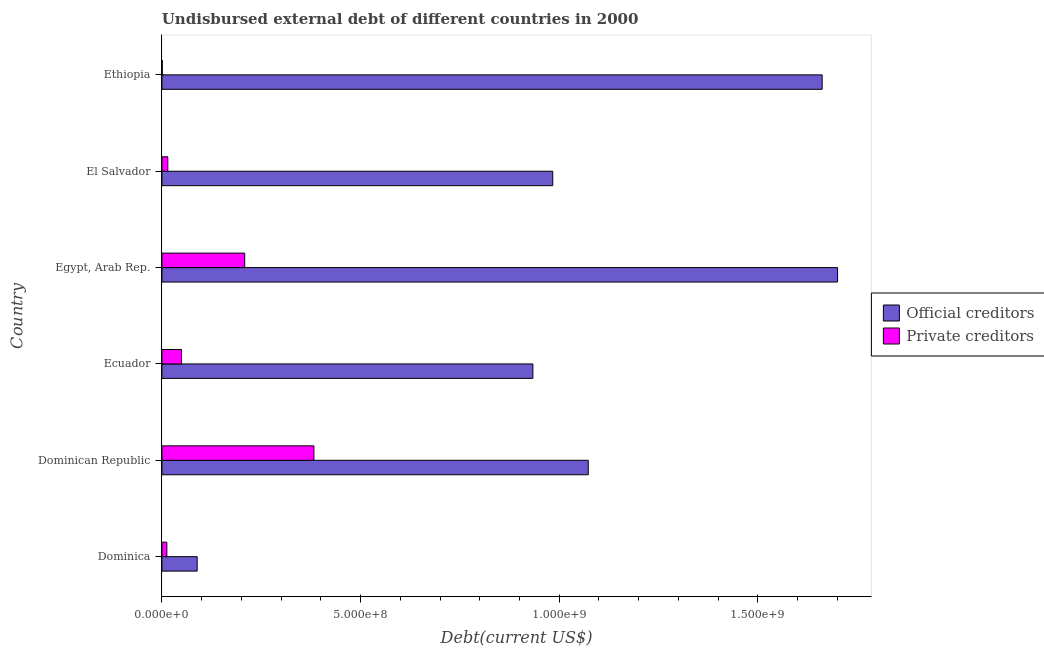Are the number of bars per tick equal to the number of legend labels?
Make the answer very short. Yes. Are the number of bars on each tick of the Y-axis equal?
Provide a short and direct response. Yes. How many bars are there on the 4th tick from the bottom?
Ensure brevity in your answer.  2. What is the label of the 5th group of bars from the top?
Your answer should be compact. Dominican Republic. In how many cases, is the number of bars for a given country not equal to the number of legend labels?
Give a very brief answer. 0. What is the undisbursed external debt of official creditors in El Salvador?
Offer a very short reply. 9.84e+08. Across all countries, what is the maximum undisbursed external debt of official creditors?
Offer a very short reply. 1.70e+09. Across all countries, what is the minimum undisbursed external debt of private creditors?
Provide a succinct answer. 9.53e+05. In which country was the undisbursed external debt of private creditors maximum?
Your answer should be compact. Dominican Republic. In which country was the undisbursed external debt of private creditors minimum?
Offer a terse response. Ethiopia. What is the total undisbursed external debt of private creditors in the graph?
Provide a short and direct response. 6.69e+08. What is the difference between the undisbursed external debt of private creditors in Ecuador and that in Egypt, Arab Rep.?
Make the answer very short. -1.59e+08. What is the difference between the undisbursed external debt of official creditors in Ethiopia and the undisbursed external debt of private creditors in Egypt, Arab Rep.?
Provide a short and direct response. 1.45e+09. What is the average undisbursed external debt of official creditors per country?
Your answer should be very brief. 1.07e+09. What is the difference between the undisbursed external debt of official creditors and undisbursed external debt of private creditors in Ethiopia?
Ensure brevity in your answer.  1.66e+09. In how many countries, is the undisbursed external debt of private creditors greater than 1100000000 US$?
Give a very brief answer. 0. Is the difference between the undisbursed external debt of private creditors in Egypt, Arab Rep. and Ethiopia greater than the difference between the undisbursed external debt of official creditors in Egypt, Arab Rep. and Ethiopia?
Make the answer very short. Yes. What is the difference between the highest and the second highest undisbursed external debt of official creditors?
Keep it short and to the point. 3.88e+07. What is the difference between the highest and the lowest undisbursed external debt of official creditors?
Provide a succinct answer. 1.61e+09. What does the 2nd bar from the top in El Salvador represents?
Provide a succinct answer. Official creditors. What does the 2nd bar from the bottom in Egypt, Arab Rep. represents?
Give a very brief answer. Private creditors. Are all the bars in the graph horizontal?
Keep it short and to the point. Yes. How many countries are there in the graph?
Your answer should be very brief. 6. Are the values on the major ticks of X-axis written in scientific E-notation?
Your answer should be very brief. Yes. Does the graph contain any zero values?
Offer a very short reply. No. What is the title of the graph?
Ensure brevity in your answer.  Undisbursed external debt of different countries in 2000. Does "Import" appear as one of the legend labels in the graph?
Your answer should be compact. No. What is the label or title of the X-axis?
Provide a short and direct response. Debt(current US$). What is the label or title of the Y-axis?
Provide a succinct answer. Country. What is the Debt(current US$) in Official creditors in Dominica?
Give a very brief answer. 8.88e+07. What is the Debt(current US$) in Private creditors in Dominica?
Make the answer very short. 1.25e+07. What is the Debt(current US$) of Official creditors in Dominican Republic?
Give a very brief answer. 1.07e+09. What is the Debt(current US$) in Private creditors in Dominican Republic?
Ensure brevity in your answer.  3.83e+08. What is the Debt(current US$) of Official creditors in Ecuador?
Provide a short and direct response. 9.34e+08. What is the Debt(current US$) of Private creditors in Ecuador?
Ensure brevity in your answer.  4.93e+07. What is the Debt(current US$) in Official creditors in Egypt, Arab Rep.?
Offer a very short reply. 1.70e+09. What is the Debt(current US$) in Private creditors in Egypt, Arab Rep.?
Ensure brevity in your answer.  2.08e+08. What is the Debt(current US$) of Official creditors in El Salvador?
Your answer should be very brief. 9.84e+08. What is the Debt(current US$) of Private creditors in El Salvador?
Ensure brevity in your answer.  1.49e+07. What is the Debt(current US$) in Official creditors in Ethiopia?
Offer a very short reply. 1.66e+09. What is the Debt(current US$) of Private creditors in Ethiopia?
Offer a terse response. 9.53e+05. Across all countries, what is the maximum Debt(current US$) of Official creditors?
Ensure brevity in your answer.  1.70e+09. Across all countries, what is the maximum Debt(current US$) of Private creditors?
Make the answer very short. 3.83e+08. Across all countries, what is the minimum Debt(current US$) in Official creditors?
Ensure brevity in your answer.  8.88e+07. Across all countries, what is the minimum Debt(current US$) of Private creditors?
Offer a terse response. 9.53e+05. What is the total Debt(current US$) in Official creditors in the graph?
Offer a terse response. 6.44e+09. What is the total Debt(current US$) of Private creditors in the graph?
Provide a short and direct response. 6.69e+08. What is the difference between the Debt(current US$) in Official creditors in Dominica and that in Dominican Republic?
Provide a succinct answer. -9.84e+08. What is the difference between the Debt(current US$) of Private creditors in Dominica and that in Dominican Republic?
Make the answer very short. -3.70e+08. What is the difference between the Debt(current US$) of Official creditors in Dominica and that in Ecuador?
Your response must be concise. -8.45e+08. What is the difference between the Debt(current US$) of Private creditors in Dominica and that in Ecuador?
Provide a succinct answer. -3.68e+07. What is the difference between the Debt(current US$) in Official creditors in Dominica and that in Egypt, Arab Rep.?
Keep it short and to the point. -1.61e+09. What is the difference between the Debt(current US$) of Private creditors in Dominica and that in Egypt, Arab Rep.?
Your response must be concise. -1.96e+08. What is the difference between the Debt(current US$) of Official creditors in Dominica and that in El Salvador?
Offer a terse response. -8.95e+08. What is the difference between the Debt(current US$) in Private creditors in Dominica and that in El Salvador?
Your answer should be very brief. -2.40e+06. What is the difference between the Debt(current US$) of Official creditors in Dominica and that in Ethiopia?
Provide a succinct answer. -1.57e+09. What is the difference between the Debt(current US$) of Private creditors in Dominica and that in Ethiopia?
Ensure brevity in your answer.  1.15e+07. What is the difference between the Debt(current US$) of Official creditors in Dominican Republic and that in Ecuador?
Your answer should be compact. 1.39e+08. What is the difference between the Debt(current US$) of Private creditors in Dominican Republic and that in Ecuador?
Offer a terse response. 3.33e+08. What is the difference between the Debt(current US$) in Official creditors in Dominican Republic and that in Egypt, Arab Rep.?
Make the answer very short. -6.27e+08. What is the difference between the Debt(current US$) of Private creditors in Dominican Republic and that in Egypt, Arab Rep.?
Provide a short and direct response. 1.74e+08. What is the difference between the Debt(current US$) in Official creditors in Dominican Republic and that in El Salvador?
Your answer should be compact. 8.94e+07. What is the difference between the Debt(current US$) of Private creditors in Dominican Republic and that in El Salvador?
Give a very brief answer. 3.68e+08. What is the difference between the Debt(current US$) in Official creditors in Dominican Republic and that in Ethiopia?
Give a very brief answer. -5.89e+08. What is the difference between the Debt(current US$) of Private creditors in Dominican Republic and that in Ethiopia?
Provide a short and direct response. 3.82e+08. What is the difference between the Debt(current US$) in Official creditors in Ecuador and that in Egypt, Arab Rep.?
Offer a very short reply. -7.67e+08. What is the difference between the Debt(current US$) in Private creditors in Ecuador and that in Egypt, Arab Rep.?
Offer a very short reply. -1.59e+08. What is the difference between the Debt(current US$) in Official creditors in Ecuador and that in El Salvador?
Provide a short and direct response. -5.00e+07. What is the difference between the Debt(current US$) of Private creditors in Ecuador and that in El Salvador?
Give a very brief answer. 3.44e+07. What is the difference between the Debt(current US$) in Official creditors in Ecuador and that in Ethiopia?
Your response must be concise. -7.28e+08. What is the difference between the Debt(current US$) in Private creditors in Ecuador and that in Ethiopia?
Ensure brevity in your answer.  4.83e+07. What is the difference between the Debt(current US$) in Official creditors in Egypt, Arab Rep. and that in El Salvador?
Ensure brevity in your answer.  7.17e+08. What is the difference between the Debt(current US$) of Private creditors in Egypt, Arab Rep. and that in El Salvador?
Offer a terse response. 1.94e+08. What is the difference between the Debt(current US$) in Official creditors in Egypt, Arab Rep. and that in Ethiopia?
Make the answer very short. 3.88e+07. What is the difference between the Debt(current US$) of Private creditors in Egypt, Arab Rep. and that in Ethiopia?
Offer a very short reply. 2.07e+08. What is the difference between the Debt(current US$) of Official creditors in El Salvador and that in Ethiopia?
Offer a very short reply. -6.78e+08. What is the difference between the Debt(current US$) of Private creditors in El Salvador and that in Ethiopia?
Your answer should be very brief. 1.39e+07. What is the difference between the Debt(current US$) of Official creditors in Dominica and the Debt(current US$) of Private creditors in Dominican Republic?
Offer a terse response. -2.94e+08. What is the difference between the Debt(current US$) of Official creditors in Dominica and the Debt(current US$) of Private creditors in Ecuador?
Offer a very short reply. 3.95e+07. What is the difference between the Debt(current US$) of Official creditors in Dominica and the Debt(current US$) of Private creditors in Egypt, Arab Rep.?
Your answer should be compact. -1.20e+08. What is the difference between the Debt(current US$) of Official creditors in Dominica and the Debt(current US$) of Private creditors in El Salvador?
Offer a terse response. 7.39e+07. What is the difference between the Debt(current US$) in Official creditors in Dominica and the Debt(current US$) in Private creditors in Ethiopia?
Provide a short and direct response. 8.78e+07. What is the difference between the Debt(current US$) in Official creditors in Dominican Republic and the Debt(current US$) in Private creditors in Ecuador?
Your response must be concise. 1.02e+09. What is the difference between the Debt(current US$) in Official creditors in Dominican Republic and the Debt(current US$) in Private creditors in Egypt, Arab Rep.?
Offer a very short reply. 8.65e+08. What is the difference between the Debt(current US$) of Official creditors in Dominican Republic and the Debt(current US$) of Private creditors in El Salvador?
Ensure brevity in your answer.  1.06e+09. What is the difference between the Debt(current US$) in Official creditors in Dominican Republic and the Debt(current US$) in Private creditors in Ethiopia?
Offer a terse response. 1.07e+09. What is the difference between the Debt(current US$) of Official creditors in Ecuador and the Debt(current US$) of Private creditors in Egypt, Arab Rep.?
Your answer should be very brief. 7.25e+08. What is the difference between the Debt(current US$) in Official creditors in Ecuador and the Debt(current US$) in Private creditors in El Salvador?
Provide a short and direct response. 9.19e+08. What is the difference between the Debt(current US$) in Official creditors in Ecuador and the Debt(current US$) in Private creditors in Ethiopia?
Your response must be concise. 9.33e+08. What is the difference between the Debt(current US$) in Official creditors in Egypt, Arab Rep. and the Debt(current US$) in Private creditors in El Salvador?
Provide a short and direct response. 1.69e+09. What is the difference between the Debt(current US$) of Official creditors in Egypt, Arab Rep. and the Debt(current US$) of Private creditors in Ethiopia?
Give a very brief answer. 1.70e+09. What is the difference between the Debt(current US$) in Official creditors in El Salvador and the Debt(current US$) in Private creditors in Ethiopia?
Your answer should be very brief. 9.83e+08. What is the average Debt(current US$) of Official creditors per country?
Keep it short and to the point. 1.07e+09. What is the average Debt(current US$) in Private creditors per country?
Ensure brevity in your answer.  1.11e+08. What is the difference between the Debt(current US$) in Official creditors and Debt(current US$) in Private creditors in Dominica?
Keep it short and to the point. 7.63e+07. What is the difference between the Debt(current US$) in Official creditors and Debt(current US$) in Private creditors in Dominican Republic?
Give a very brief answer. 6.90e+08. What is the difference between the Debt(current US$) in Official creditors and Debt(current US$) in Private creditors in Ecuador?
Your response must be concise. 8.84e+08. What is the difference between the Debt(current US$) in Official creditors and Debt(current US$) in Private creditors in Egypt, Arab Rep.?
Keep it short and to the point. 1.49e+09. What is the difference between the Debt(current US$) in Official creditors and Debt(current US$) in Private creditors in El Salvador?
Your response must be concise. 9.69e+08. What is the difference between the Debt(current US$) of Official creditors and Debt(current US$) of Private creditors in Ethiopia?
Offer a terse response. 1.66e+09. What is the ratio of the Debt(current US$) in Official creditors in Dominica to that in Dominican Republic?
Give a very brief answer. 0.08. What is the ratio of the Debt(current US$) in Private creditors in Dominica to that in Dominican Republic?
Offer a very short reply. 0.03. What is the ratio of the Debt(current US$) of Official creditors in Dominica to that in Ecuador?
Offer a very short reply. 0.1. What is the ratio of the Debt(current US$) of Private creditors in Dominica to that in Ecuador?
Your answer should be compact. 0.25. What is the ratio of the Debt(current US$) of Official creditors in Dominica to that in Egypt, Arab Rep.?
Your answer should be very brief. 0.05. What is the ratio of the Debt(current US$) in Private creditors in Dominica to that in Egypt, Arab Rep.?
Offer a terse response. 0.06. What is the ratio of the Debt(current US$) in Official creditors in Dominica to that in El Salvador?
Provide a succinct answer. 0.09. What is the ratio of the Debt(current US$) in Private creditors in Dominica to that in El Salvador?
Make the answer very short. 0.84. What is the ratio of the Debt(current US$) in Official creditors in Dominica to that in Ethiopia?
Ensure brevity in your answer.  0.05. What is the ratio of the Debt(current US$) in Private creditors in Dominica to that in Ethiopia?
Offer a very short reply. 13.07. What is the ratio of the Debt(current US$) of Official creditors in Dominican Republic to that in Ecuador?
Provide a short and direct response. 1.15. What is the ratio of the Debt(current US$) of Private creditors in Dominican Republic to that in Ecuador?
Give a very brief answer. 7.77. What is the ratio of the Debt(current US$) in Official creditors in Dominican Republic to that in Egypt, Arab Rep.?
Ensure brevity in your answer.  0.63. What is the ratio of the Debt(current US$) in Private creditors in Dominican Republic to that in Egypt, Arab Rep.?
Offer a very short reply. 1.84. What is the ratio of the Debt(current US$) in Official creditors in Dominican Republic to that in El Salvador?
Provide a succinct answer. 1.09. What is the ratio of the Debt(current US$) of Private creditors in Dominican Republic to that in El Salvador?
Make the answer very short. 25.76. What is the ratio of the Debt(current US$) of Official creditors in Dominican Republic to that in Ethiopia?
Your answer should be compact. 0.65. What is the ratio of the Debt(current US$) in Private creditors in Dominican Republic to that in Ethiopia?
Offer a very short reply. 401.48. What is the ratio of the Debt(current US$) of Official creditors in Ecuador to that in Egypt, Arab Rep.?
Your response must be concise. 0.55. What is the ratio of the Debt(current US$) of Private creditors in Ecuador to that in Egypt, Arab Rep.?
Offer a very short reply. 0.24. What is the ratio of the Debt(current US$) in Official creditors in Ecuador to that in El Salvador?
Offer a very short reply. 0.95. What is the ratio of the Debt(current US$) in Private creditors in Ecuador to that in El Salvador?
Your answer should be compact. 3.32. What is the ratio of the Debt(current US$) of Official creditors in Ecuador to that in Ethiopia?
Provide a short and direct response. 0.56. What is the ratio of the Debt(current US$) of Private creditors in Ecuador to that in Ethiopia?
Provide a succinct answer. 51.69. What is the ratio of the Debt(current US$) of Official creditors in Egypt, Arab Rep. to that in El Salvador?
Your answer should be compact. 1.73. What is the ratio of the Debt(current US$) of Private creditors in Egypt, Arab Rep. to that in El Salvador?
Your answer should be very brief. 14.03. What is the ratio of the Debt(current US$) in Official creditors in Egypt, Arab Rep. to that in Ethiopia?
Offer a very short reply. 1.02. What is the ratio of the Debt(current US$) in Private creditors in Egypt, Arab Rep. to that in Ethiopia?
Provide a short and direct response. 218.69. What is the ratio of the Debt(current US$) in Official creditors in El Salvador to that in Ethiopia?
Your response must be concise. 0.59. What is the ratio of the Debt(current US$) in Private creditors in El Salvador to that in Ethiopia?
Provide a succinct answer. 15.59. What is the difference between the highest and the second highest Debt(current US$) in Official creditors?
Your response must be concise. 3.88e+07. What is the difference between the highest and the second highest Debt(current US$) of Private creditors?
Offer a very short reply. 1.74e+08. What is the difference between the highest and the lowest Debt(current US$) in Official creditors?
Ensure brevity in your answer.  1.61e+09. What is the difference between the highest and the lowest Debt(current US$) in Private creditors?
Provide a succinct answer. 3.82e+08. 